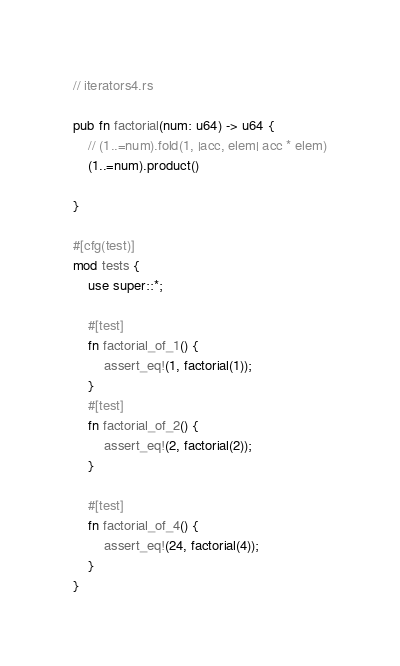<code> <loc_0><loc_0><loc_500><loc_500><_Rust_>// iterators4.rs

pub fn factorial(num: u64) -> u64 {
    // (1..=num).fold(1, |acc, elem| acc * elem)
    (1..=num).product()
    
}

#[cfg(test)]
mod tests {
    use super::*;

    #[test]
    fn factorial_of_1() {
        assert_eq!(1, factorial(1));
    }
    #[test]
    fn factorial_of_2() {
        assert_eq!(2, factorial(2));
    }

    #[test]
    fn factorial_of_4() {
        assert_eq!(24, factorial(4));
    }
}
</code> 